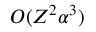<formula> <loc_0><loc_0><loc_500><loc_500>O ( Z ^ { 2 } \alpha ^ { 3 } )</formula> 